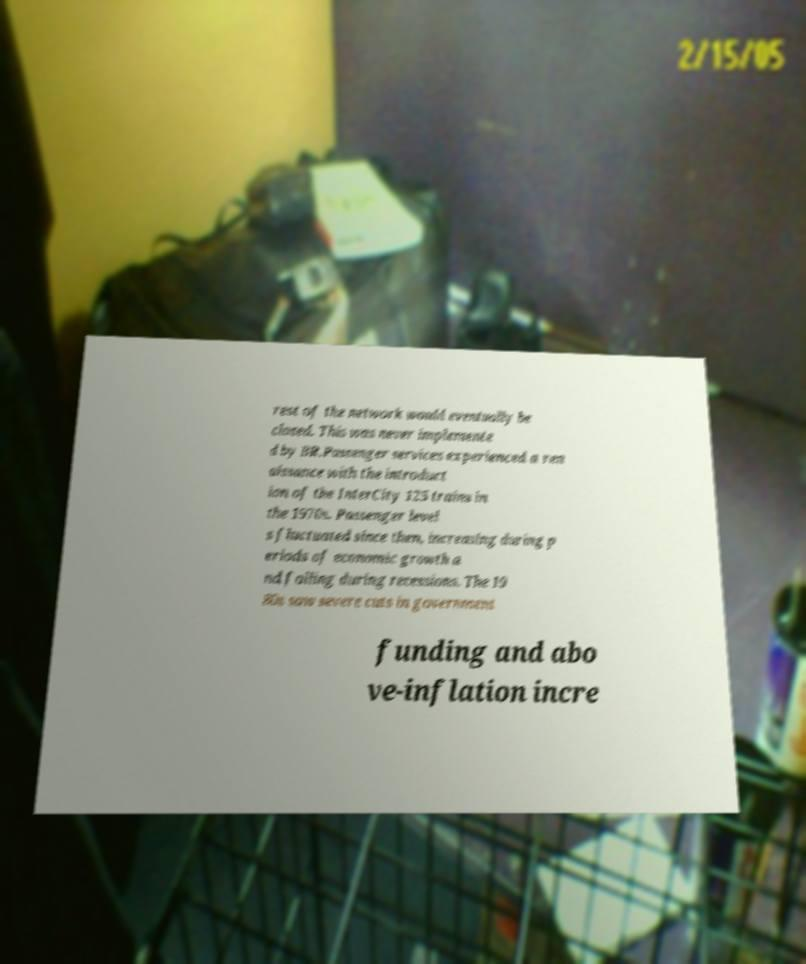Could you extract and type out the text from this image? rest of the network would eventually be closed. This was never implemente d by BR.Passenger services experienced a ren aissance with the introduct ion of the InterCity 125 trains in the 1970s. Passenger level s fluctuated since then, increasing during p eriods of economic growth a nd falling during recessions. The 19 80s saw severe cuts in government funding and abo ve-inflation incre 